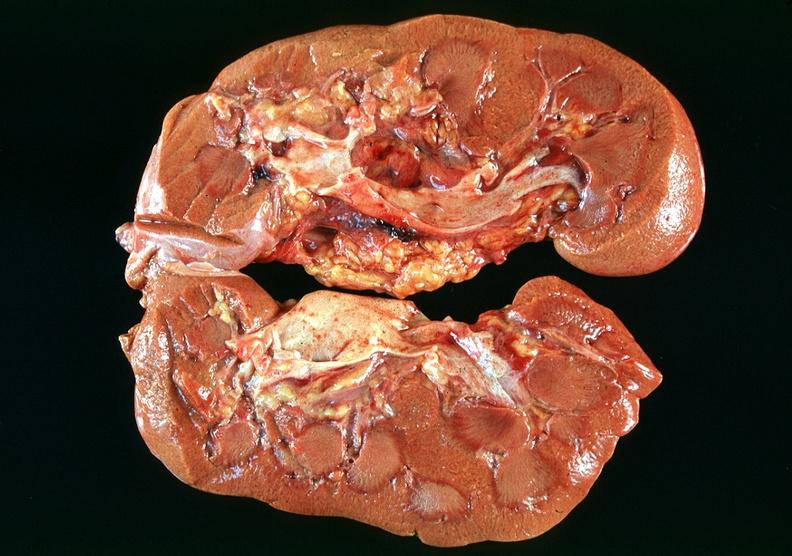how many antitrypsin does this image show kidney, acute tubular necrosis due to coagulopathy, disseminated intravascular coagulation dic, and shock, alpha-deficiency?
Answer the question using a single word or phrase. 1 